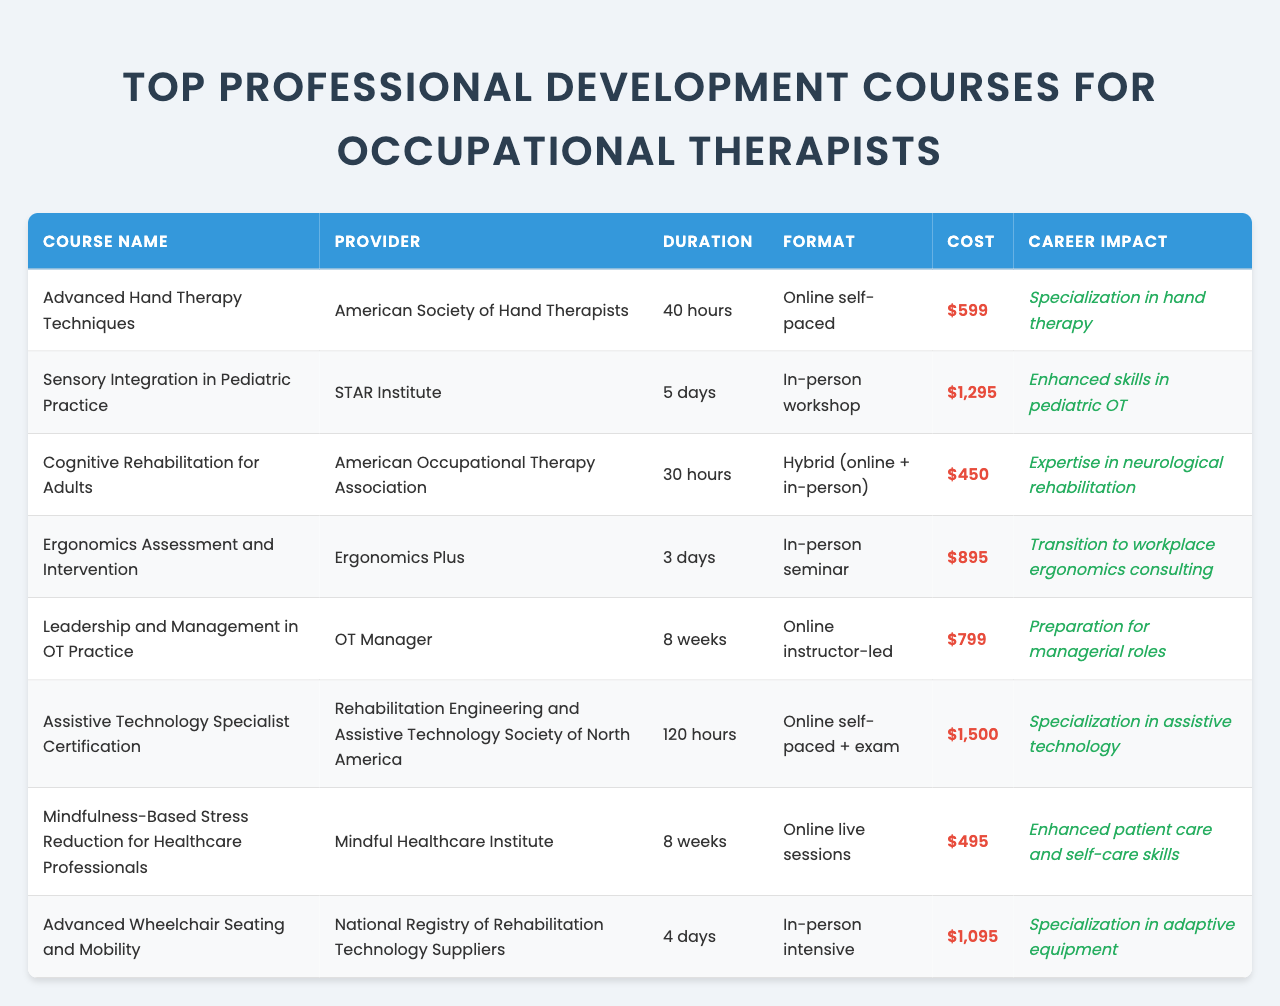What is the cost of the course "Advanced Wheelchair Seating and Mobility"? The table lists the course "Advanced Wheelchair Seating and Mobility" and shows the corresponding cost as "$1,095".
Answer: $1,095 Which provider offers the "Cognitive Rehabilitation for Adults" course? The table indicates that the provider for "Cognitive Rehabilitation for Adults" is the "American Occupational Therapy Association".
Answer: American Occupational Therapy Association How long is the "Mindfulness-Based Stress Reduction for Healthcare Professionals" course? The table specifies that the duration of the "Mindfulness-Based Stress Reduction for Healthcare Professionals" course is "8 weeks".
Answer: 8 weeks Which course has the highest cost? By examining the costs listed in the table, "Assistive Technology Specialist Certification" at "$1,500" is identified as the highest cost among the courses.
Answer: $1,500 What is the duration of the "Sensory Integration in Pediatric Practice" course? The table states that the duration for "Sensory Integration in Pediatric Practice" is "5 days".
Answer: 5 days Is there any course that costs less than $500? Looking at all the costs listed in the table, the course "Mindfulness-Based Stress Reduction for Healthcare Professionals" is priced at "$495", which is under $500.
Answer: Yes What is the average cost of the courses listed? The costs are: $599, $1,295, $450, $895, $799, $1,500, $495, and $1,095. Adding them gives a total of $6,133 and dividing by 8 courses results in an average cost of $766.625, which can be rounded to $766.63 for simplicity.
Answer: $766.63 Which course focuses on ergonomic assessment? The table indicates that the course "Ergonomics Assessment and Intervention" is focused on ergonomic assessment.
Answer: Ergonomics Assessment and Intervention If someone completes the "Leadership and Management in OT Practice" course, what kind of roles might they prepare for? The career impact listed beside this course indicates preparation for managerial roles.
Answer: Managerial roles Which course offers specialization in assistive technology? The course "Assistive Technology Specialist Certification" explicitly states that it is for specialization in assistive technology.
Answer: Assistive Technology Specialist Certification What is the total number of hours for the "Advanced Hand Therapy Techniques" course? The table shows that the "Advanced Hand Therapy Techniques" course has a duration of "40 hours".
Answer: 40 hours 